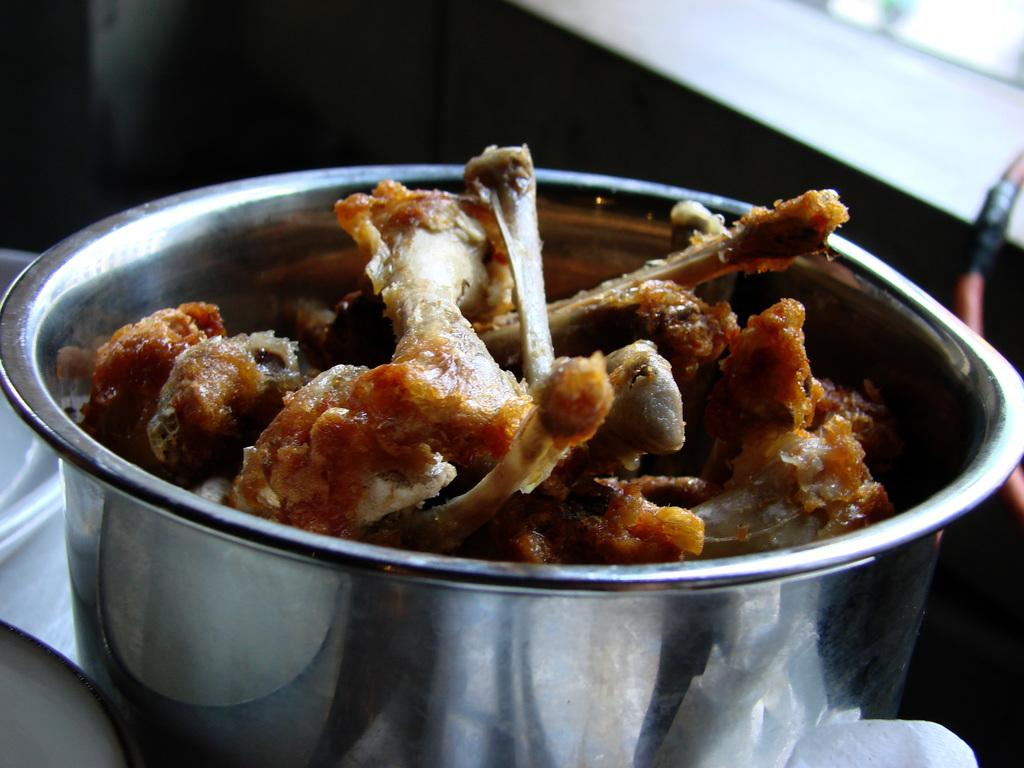What is on the table in the image? There is a bowl on a table in the image. What is inside the bowl? The bowl is filled with bones. How does the bowl move around on the table in the image? The bowl does not move around on the table in the image; it is stationary. 